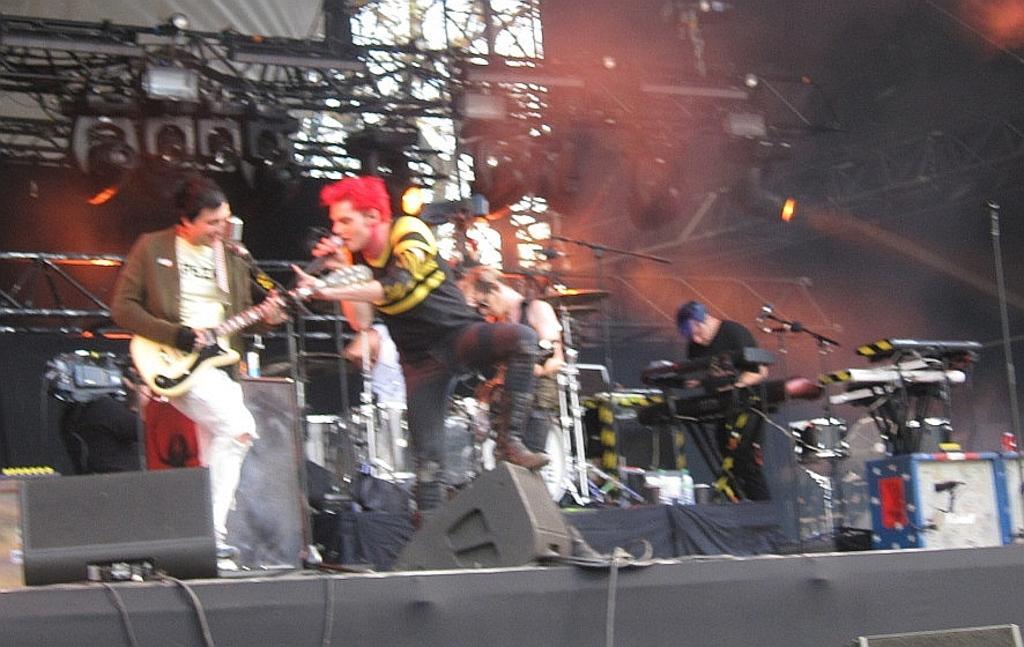Can you describe this image briefly? In the foreground of the image there is a person holding a mic and singing. In the background of the image there are people playing musical instruments. There are rods,lights. 